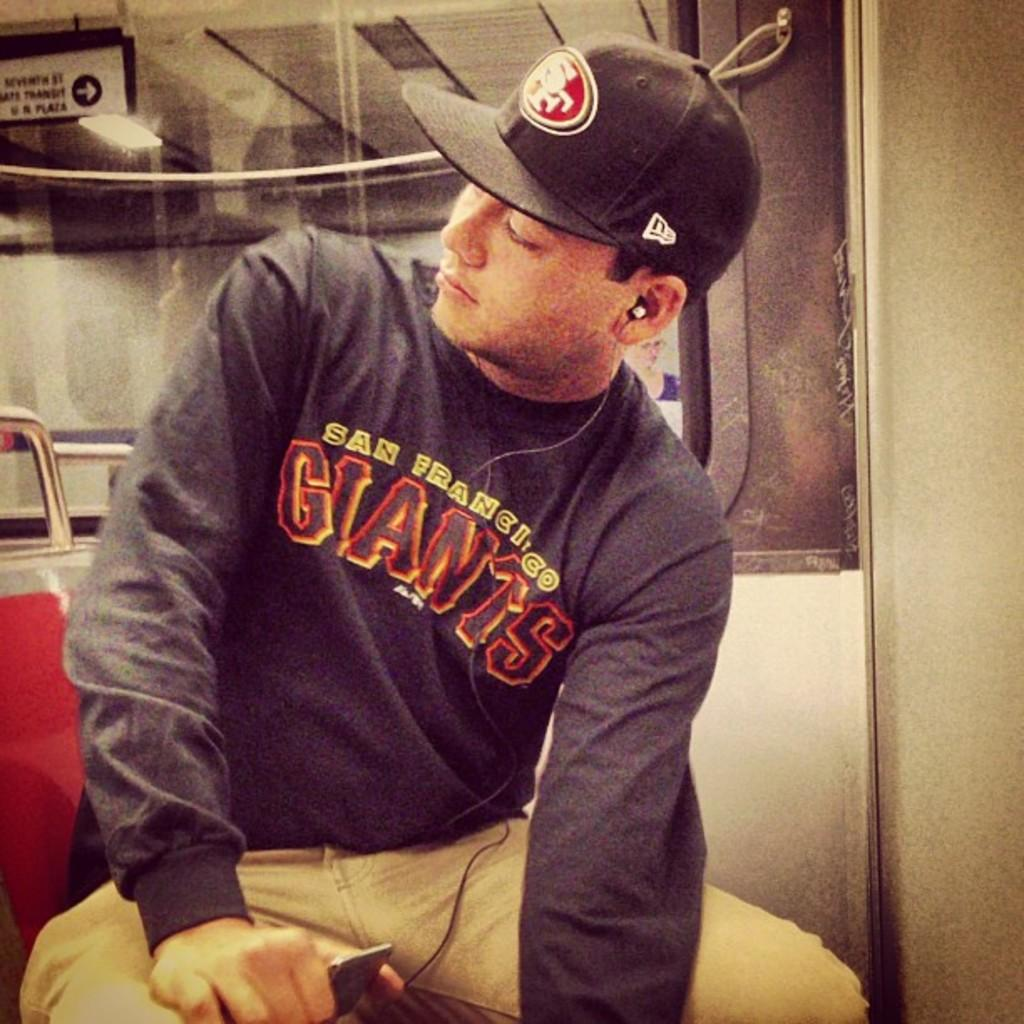What is the main subject of the image? There is a person in the image. What is the person wearing? The person is wearing a dress and a cap. What is the person holding in his hand? The person is holding a device in his hand. What can be seen in the background of the image? There is a window, a sign board with some text, and lights visible in the background of the image. Where is the best spot to rest in the image? There is no specific spot mentioned or visible in the image for resting. 